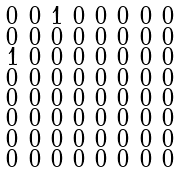<formula> <loc_0><loc_0><loc_500><loc_500>\begin{smallmatrix} 0 & 0 & 1 & 0 & 0 & 0 & 0 & 0 \\ 0 & 0 & 0 & 0 & 0 & 0 & 0 & 0 \\ 1 & 0 & 0 & 0 & 0 & 0 & 0 & 0 \\ 0 & 0 & 0 & 0 & 0 & 0 & 0 & 0 \\ 0 & 0 & 0 & 0 & 0 & 0 & 0 & 0 \\ 0 & 0 & 0 & 0 & 0 & 0 & 0 & 0 \\ 0 & 0 & 0 & 0 & 0 & 0 & 0 & 0 \\ 0 & 0 & 0 & 0 & 0 & 0 & 0 & 0 \end{smallmatrix}</formula> 